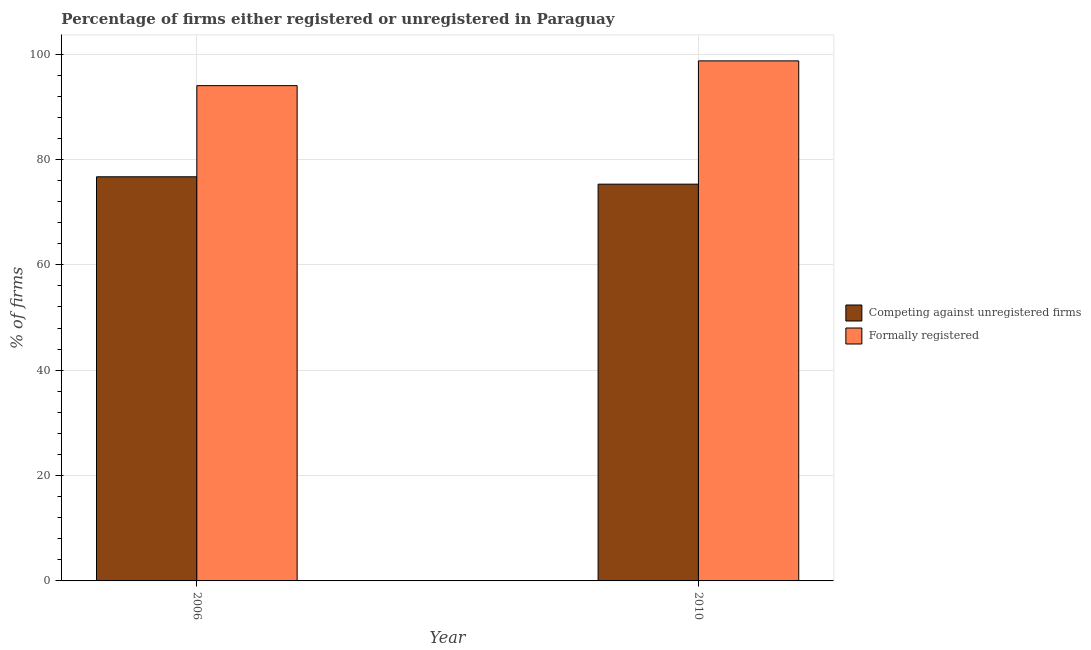How many different coloured bars are there?
Provide a short and direct response. 2. Are the number of bars on each tick of the X-axis equal?
Provide a short and direct response. Yes. What is the percentage of registered firms in 2010?
Offer a very short reply. 75.3. Across all years, what is the maximum percentage of formally registered firms?
Give a very brief answer. 98.7. Across all years, what is the minimum percentage of registered firms?
Give a very brief answer. 75.3. In which year was the percentage of registered firms maximum?
Give a very brief answer. 2006. What is the total percentage of registered firms in the graph?
Keep it short and to the point. 152. What is the difference between the percentage of registered firms in 2006 and that in 2010?
Provide a succinct answer. 1.4. What is the difference between the percentage of formally registered firms in 2010 and the percentage of registered firms in 2006?
Ensure brevity in your answer.  4.7. What is the average percentage of formally registered firms per year?
Your response must be concise. 96.35. What is the ratio of the percentage of registered firms in 2006 to that in 2010?
Offer a terse response. 1.02. What does the 1st bar from the left in 2010 represents?
Provide a short and direct response. Competing against unregistered firms. What does the 1st bar from the right in 2006 represents?
Make the answer very short. Formally registered. How many bars are there?
Your answer should be very brief. 4. Are all the bars in the graph horizontal?
Your answer should be very brief. No. How are the legend labels stacked?
Your answer should be very brief. Vertical. What is the title of the graph?
Keep it short and to the point. Percentage of firms either registered or unregistered in Paraguay. What is the label or title of the Y-axis?
Offer a terse response. % of firms. What is the % of firms of Competing against unregistered firms in 2006?
Offer a terse response. 76.7. What is the % of firms of Formally registered in 2006?
Your response must be concise. 94. What is the % of firms in Competing against unregistered firms in 2010?
Make the answer very short. 75.3. What is the % of firms of Formally registered in 2010?
Your answer should be very brief. 98.7. Across all years, what is the maximum % of firms of Competing against unregistered firms?
Provide a short and direct response. 76.7. Across all years, what is the maximum % of firms of Formally registered?
Offer a terse response. 98.7. Across all years, what is the minimum % of firms in Competing against unregistered firms?
Your answer should be very brief. 75.3. Across all years, what is the minimum % of firms in Formally registered?
Your answer should be compact. 94. What is the total % of firms in Competing against unregistered firms in the graph?
Offer a terse response. 152. What is the total % of firms in Formally registered in the graph?
Make the answer very short. 192.7. What is the difference between the % of firms in Competing against unregistered firms in 2006 and that in 2010?
Make the answer very short. 1.4. What is the average % of firms of Competing against unregistered firms per year?
Provide a succinct answer. 76. What is the average % of firms of Formally registered per year?
Your answer should be very brief. 96.35. In the year 2006, what is the difference between the % of firms in Competing against unregistered firms and % of firms in Formally registered?
Offer a very short reply. -17.3. In the year 2010, what is the difference between the % of firms of Competing against unregistered firms and % of firms of Formally registered?
Provide a short and direct response. -23.4. What is the ratio of the % of firms in Competing against unregistered firms in 2006 to that in 2010?
Give a very brief answer. 1.02. What is the ratio of the % of firms of Formally registered in 2006 to that in 2010?
Provide a succinct answer. 0.95. What is the difference between the highest and the second highest % of firms of Competing against unregistered firms?
Offer a very short reply. 1.4. What is the difference between the highest and the lowest % of firms of Competing against unregistered firms?
Give a very brief answer. 1.4. 